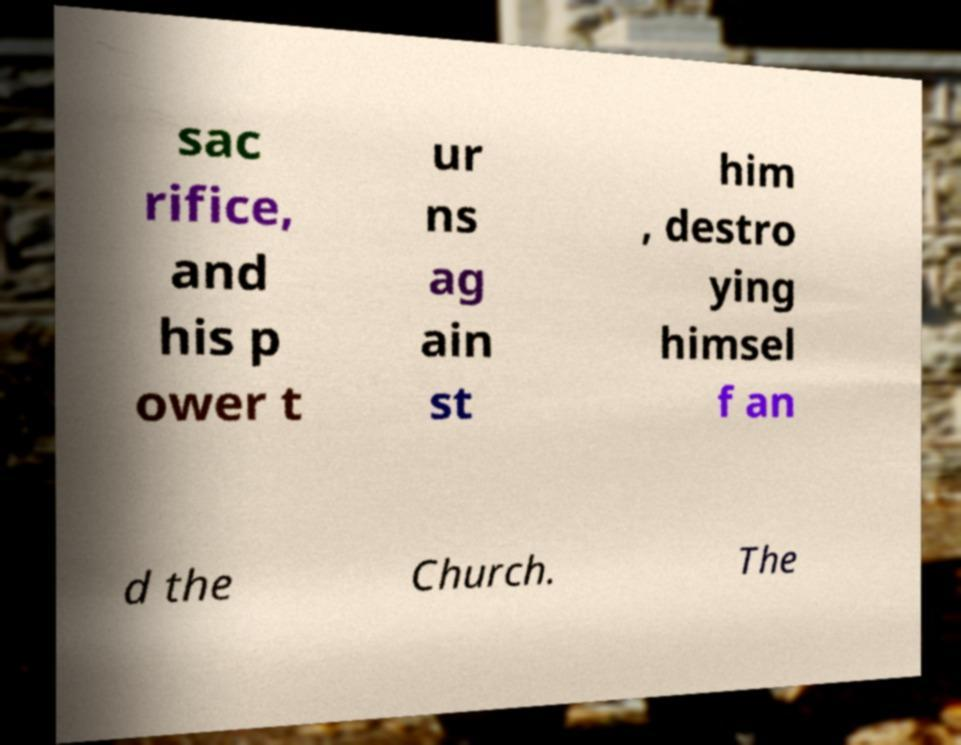What messages or text are displayed in this image? I need them in a readable, typed format. sac rifice, and his p ower t ur ns ag ain st him , destro ying himsel f an d the Church. The 